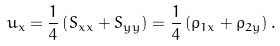Convert formula to latex. <formula><loc_0><loc_0><loc_500><loc_500>u _ { x } = \frac { 1 } { 4 } \left ( S _ { x x } + S _ { y y } \right ) = \frac { 1 } { 4 } \left ( \rho _ { 1 x } + \rho _ { 2 y } \right ) .</formula> 